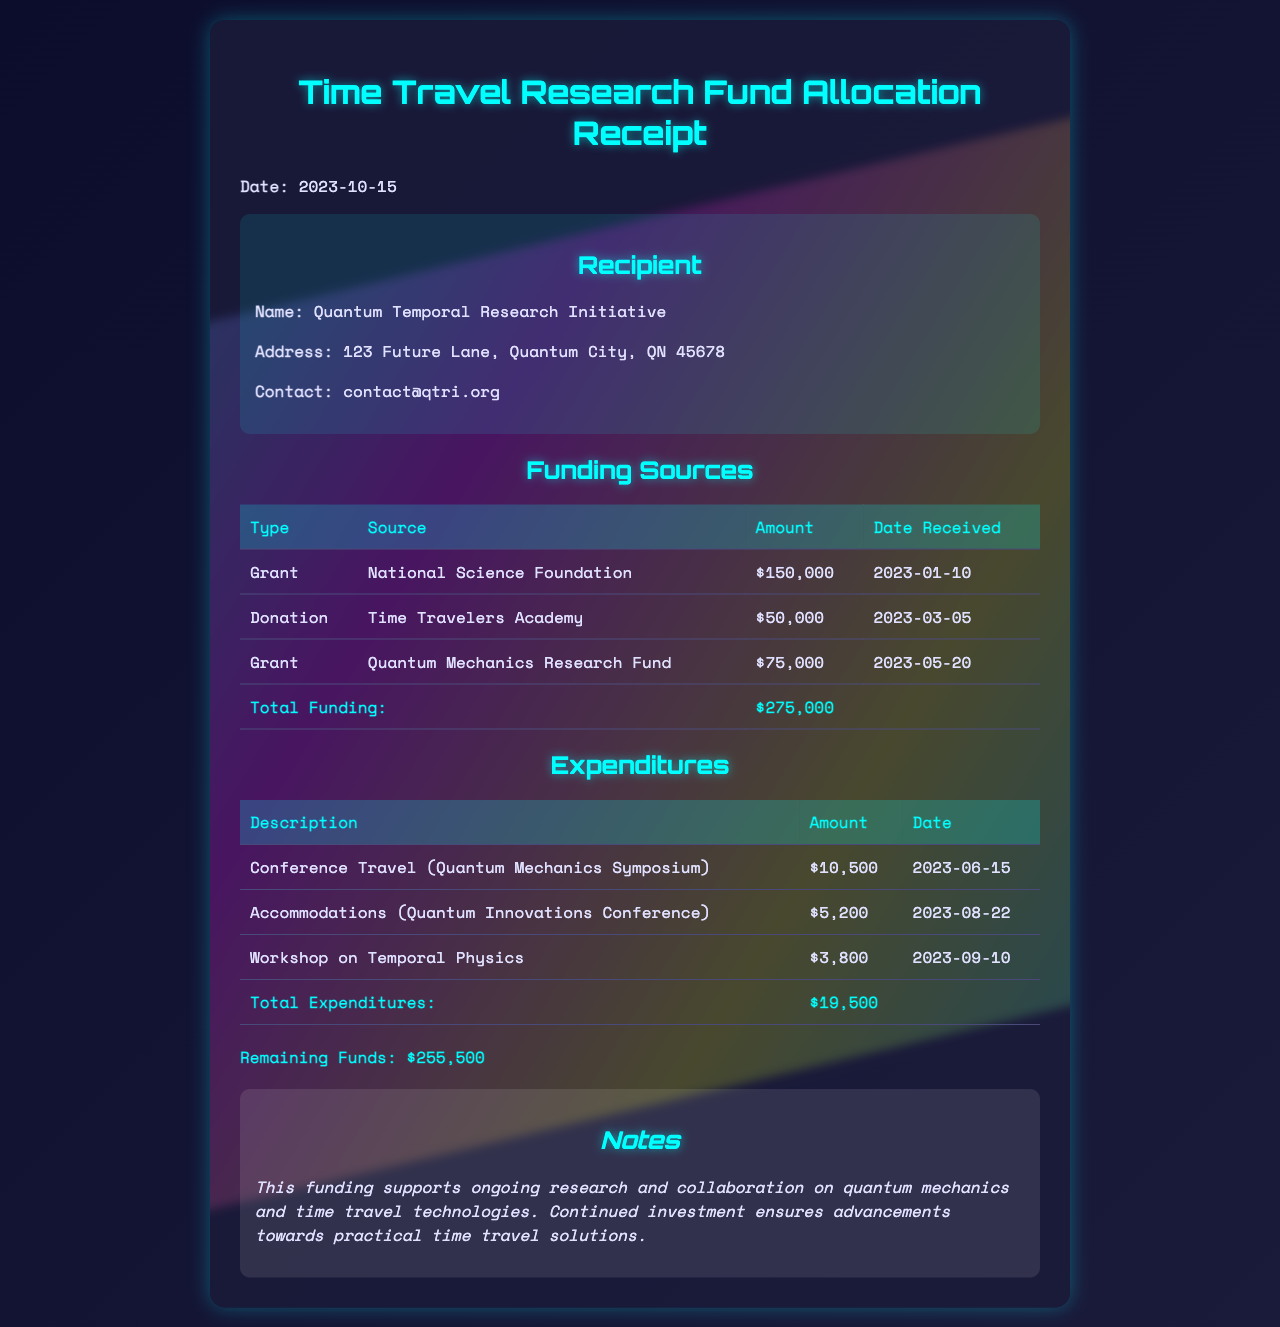What is the name of the recipient? The document specifies that the recipient is the "Quantum Temporal Research Initiative."
Answer: Quantum Temporal Research Initiative What is the total funding amount received? The total funding is detailed in the "Total Funding" row of the Funding Sources table, which sums to $275,000.
Answer: $275,000 When was the National Science Foundation grant received? The document states that this grant was received on "2023-01-10."
Answer: 2023-01-10 What is the total amount spent on conference travel? The expenditures section includes travel for the Quantum Mechanics Symposium, totaling $10,500.
Answer: $10,500 How many donations were listed in the funding sources? There are two funding sources categorized as donations in the document.
Answer: 1 What was the date of the Quantum Innovations Conference for accommodations? The expenditures section notes that accommodations were for this conference on "2023-08-22."
Answer: 2023-08-22 What is the remaining funds after expenditures? The remaining funds are calculated as total funding minus total expenditures, amounting to $255,500.
Answer: $255,500 What type of projects does the funding support according to the notes? According to the notes in the document, the funding supports "ongoing research and collaboration on quantum mechanics and time travel technologies."
Answer: ongoing research and collaboration on quantum mechanics and time travel technologies What is the total amount spent on all expenditures combined? The total expenditures listed amount to $19,500 as summarized in the expenditures table.
Answer: $19,500 